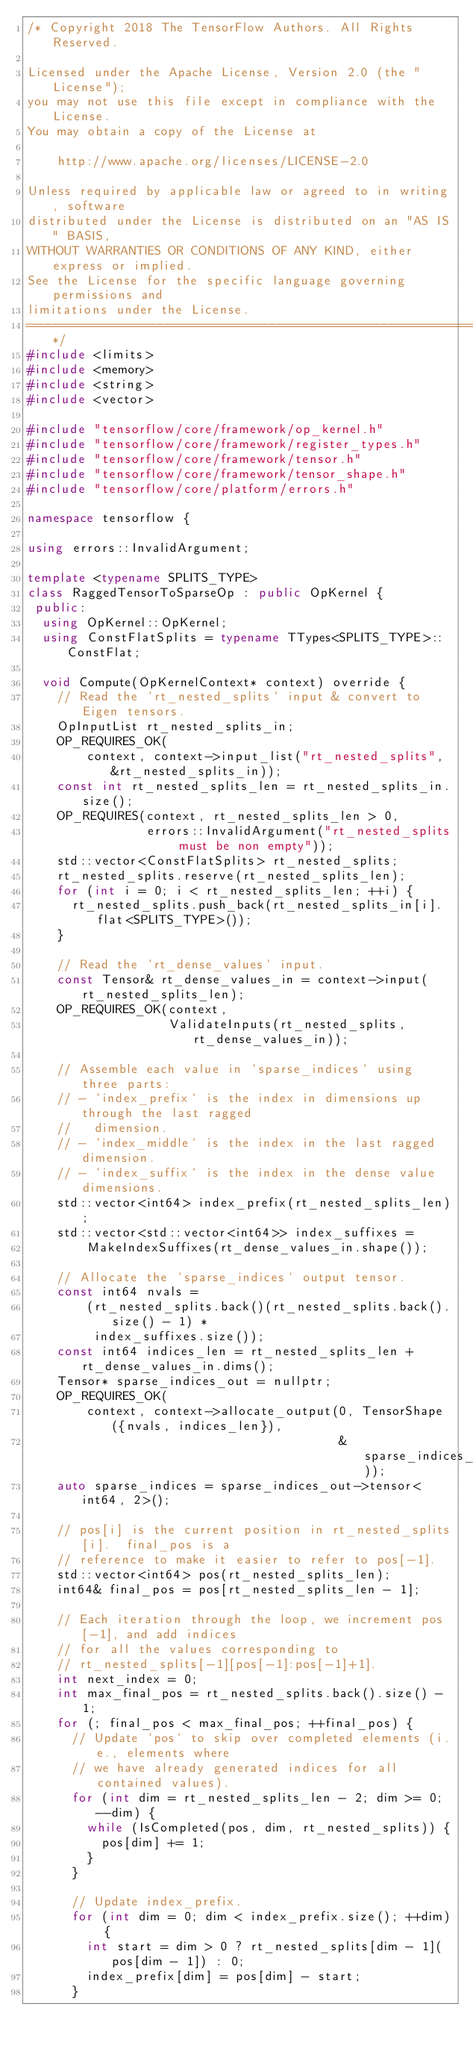Convert code to text. <code><loc_0><loc_0><loc_500><loc_500><_C++_>/* Copyright 2018 The TensorFlow Authors. All Rights Reserved.

Licensed under the Apache License, Version 2.0 (the "License");
you may not use this file except in compliance with the License.
You may obtain a copy of the License at

    http://www.apache.org/licenses/LICENSE-2.0

Unless required by applicable law or agreed to in writing, software
distributed under the License is distributed on an "AS IS" BASIS,
WITHOUT WARRANTIES OR CONDITIONS OF ANY KIND, either express or implied.
See the License for the specific language governing permissions and
limitations under the License.
==============================================================================*/
#include <limits>
#include <memory>
#include <string>
#include <vector>

#include "tensorflow/core/framework/op_kernel.h"
#include "tensorflow/core/framework/register_types.h"
#include "tensorflow/core/framework/tensor.h"
#include "tensorflow/core/framework/tensor_shape.h"
#include "tensorflow/core/platform/errors.h"

namespace tensorflow {

using errors::InvalidArgument;

template <typename SPLITS_TYPE>
class RaggedTensorToSparseOp : public OpKernel {
 public:
  using OpKernel::OpKernel;
  using ConstFlatSplits = typename TTypes<SPLITS_TYPE>::ConstFlat;

  void Compute(OpKernelContext* context) override {
    // Read the `rt_nested_splits` input & convert to Eigen tensors.
    OpInputList rt_nested_splits_in;
    OP_REQUIRES_OK(
        context, context->input_list("rt_nested_splits", &rt_nested_splits_in));
    const int rt_nested_splits_len = rt_nested_splits_in.size();
    OP_REQUIRES(context, rt_nested_splits_len > 0,
                errors::InvalidArgument("rt_nested_splits must be non empty"));
    std::vector<ConstFlatSplits> rt_nested_splits;
    rt_nested_splits.reserve(rt_nested_splits_len);
    for (int i = 0; i < rt_nested_splits_len; ++i) {
      rt_nested_splits.push_back(rt_nested_splits_in[i].flat<SPLITS_TYPE>());
    }

    // Read the `rt_dense_values` input.
    const Tensor& rt_dense_values_in = context->input(rt_nested_splits_len);
    OP_REQUIRES_OK(context,
                   ValidateInputs(rt_nested_splits, rt_dense_values_in));

    // Assemble each value in `sparse_indices` using three parts:
    // - `index_prefix` is the index in dimensions up through the last ragged
    //   dimension.
    // - `index_middle` is the index in the last ragged dimension.
    // - `index_suffix` is the index in the dense value dimensions.
    std::vector<int64> index_prefix(rt_nested_splits_len);
    std::vector<std::vector<int64>> index_suffixes =
        MakeIndexSuffixes(rt_dense_values_in.shape());

    // Allocate the `sparse_indices` output tensor.
    const int64 nvals =
        (rt_nested_splits.back()(rt_nested_splits.back().size() - 1) *
         index_suffixes.size());
    const int64 indices_len = rt_nested_splits_len + rt_dense_values_in.dims();
    Tensor* sparse_indices_out = nullptr;
    OP_REQUIRES_OK(
        context, context->allocate_output(0, TensorShape({nvals, indices_len}),
                                          &sparse_indices_out));
    auto sparse_indices = sparse_indices_out->tensor<int64, 2>();

    // pos[i] is the current position in rt_nested_splits[i].  final_pos is a
    // reference to make it easier to refer to pos[-1].
    std::vector<int64> pos(rt_nested_splits_len);
    int64& final_pos = pos[rt_nested_splits_len - 1];

    // Each iteration through the loop, we increment pos[-1], and add indices
    // for all the values corresponding to
    // rt_nested_splits[-1][pos[-1]:pos[-1]+1].
    int next_index = 0;
    int max_final_pos = rt_nested_splits.back().size() - 1;
    for (; final_pos < max_final_pos; ++final_pos) {
      // Update `pos` to skip over completed elements (i.e., elements where
      // we have already generated indices for all contained values).
      for (int dim = rt_nested_splits_len - 2; dim >= 0; --dim) {
        while (IsCompleted(pos, dim, rt_nested_splits)) {
          pos[dim] += 1;
        }
      }

      // Update index_prefix.
      for (int dim = 0; dim < index_prefix.size(); ++dim) {
        int start = dim > 0 ? rt_nested_splits[dim - 1](pos[dim - 1]) : 0;
        index_prefix[dim] = pos[dim] - start;
      }
</code> 